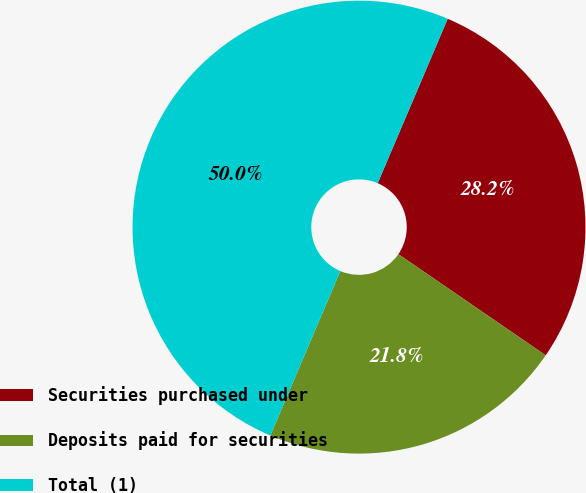Convert chart to OTSL. <chart><loc_0><loc_0><loc_500><loc_500><pie_chart><fcel>Securities purchased under<fcel>Deposits paid for securities<fcel>Total (1)<nl><fcel>28.17%<fcel>21.83%<fcel>50.0%<nl></chart> 